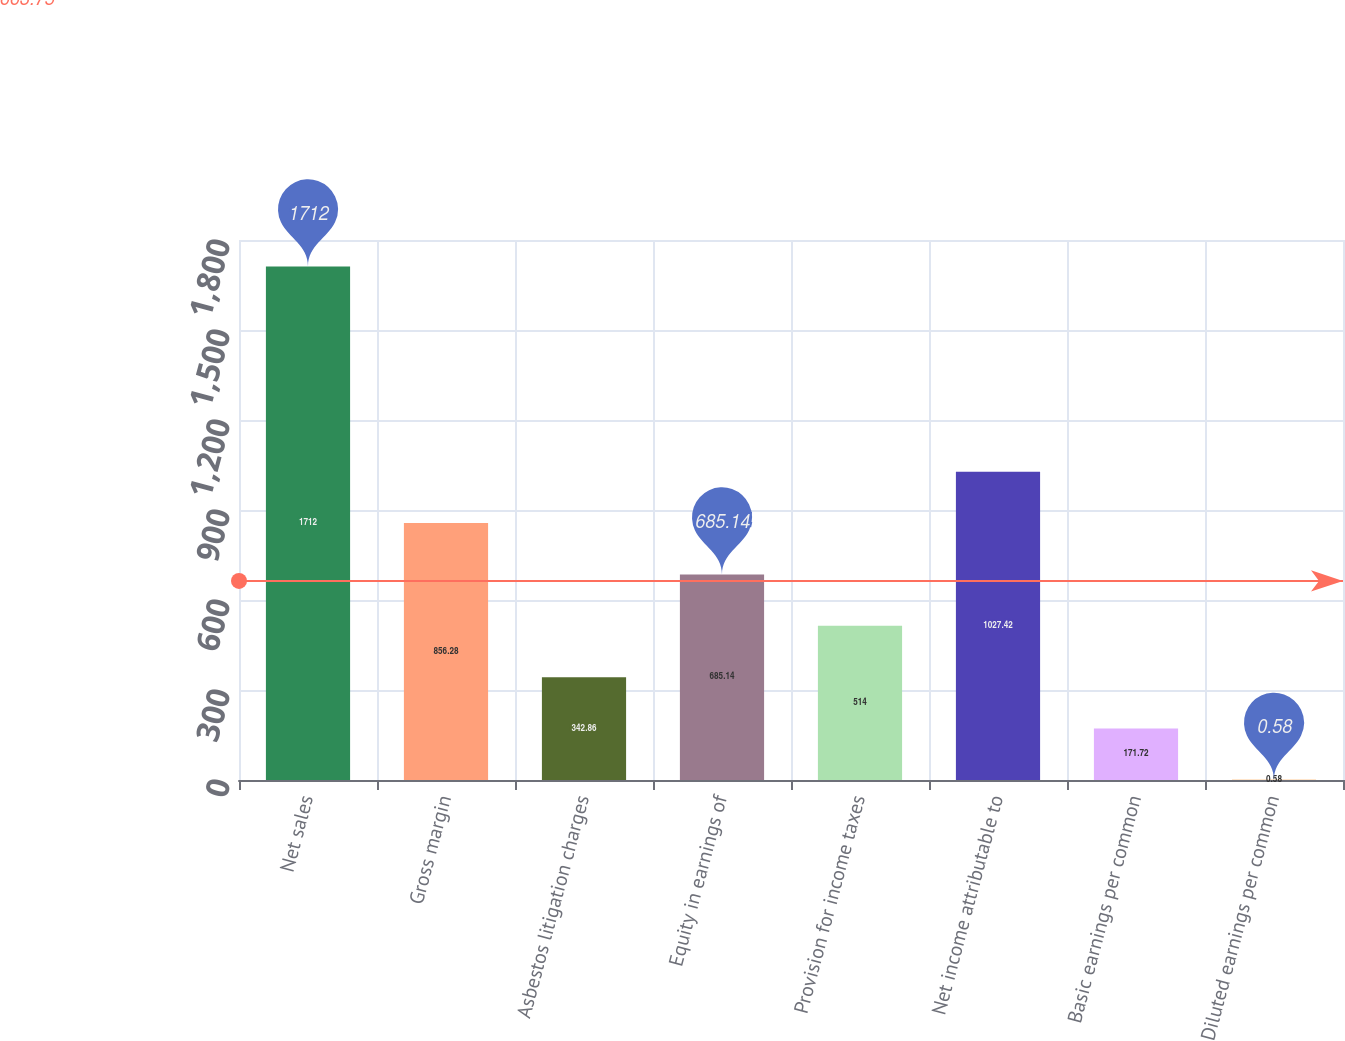Convert chart. <chart><loc_0><loc_0><loc_500><loc_500><bar_chart><fcel>Net sales<fcel>Gross margin<fcel>Asbestos litigation charges<fcel>Equity in earnings of<fcel>Provision for income taxes<fcel>Net income attributable to<fcel>Basic earnings per common<fcel>Diluted earnings per common<nl><fcel>1712<fcel>856.28<fcel>342.86<fcel>685.14<fcel>514<fcel>1027.42<fcel>171.72<fcel>0.58<nl></chart> 